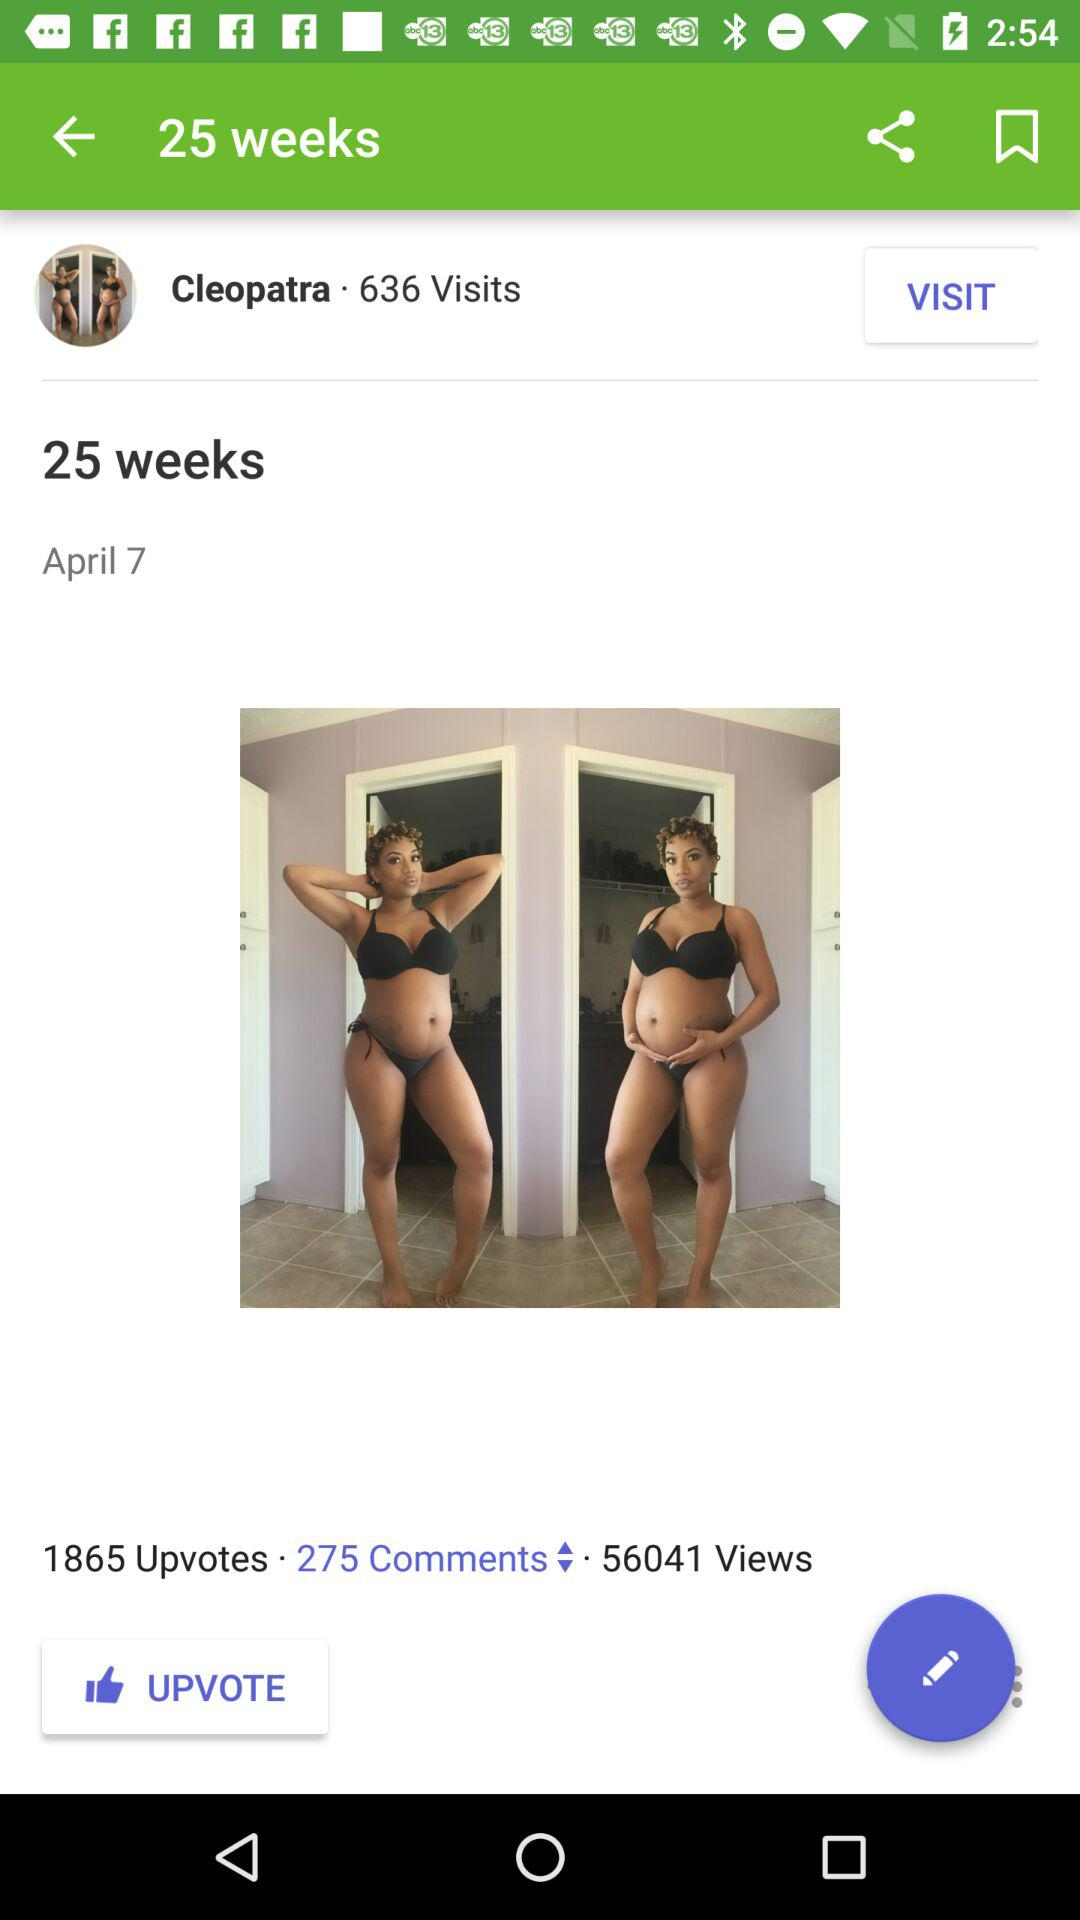How many weeks are there? There are 25 weeks. 